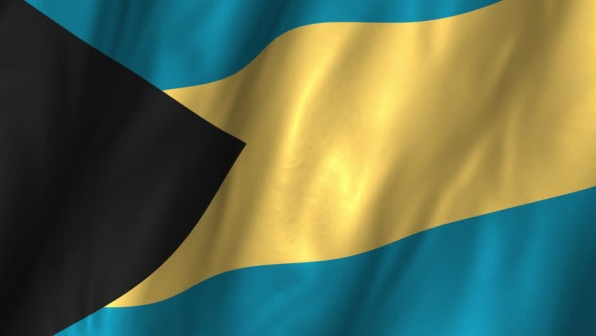What do you see happening in this image? The image shows the national flag of the Bahamas, gracefully billowing in the wind. The flag consists of three horizontal stripes: the top and bottom stripes are vibrant aquamarine, signifying the pristine waters that surround the islands, while the wider middle stripe is a bright gold, representing the beautiful, golden beaches of the Bahamas. On the left side of the flag, there's a bold black equilateral triangle that spans from the top to the bottom edges, symbolizing both the strength and determination of the Bahamian people. The precise arrangement of colors and shapes adheres to the official design, creating a visually striking representation of the nation's identity, heritage, and natural resources. 